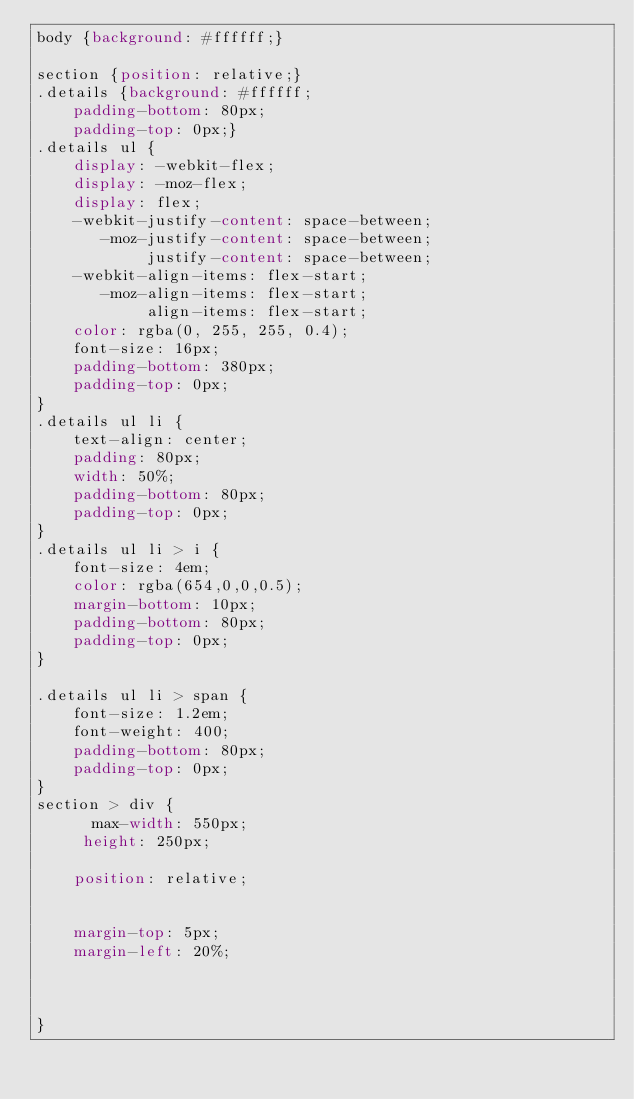Convert code to text. <code><loc_0><loc_0><loc_500><loc_500><_CSS_>body {background: #ffffff;}

section {position: relative;}
.details {background: #ffffff;
    padding-bottom: 80px;
    padding-top: 0px;}
.details ul {
    display: -webkit-flex;
    display: -moz-flex;
    display: flex;
    -webkit-justify-content: space-between;
       -moz-justify-content: space-between;
            justify-content: space-between;
    -webkit-align-items: flex-start;
       -moz-align-items: flex-start;
            align-items: flex-start;
    color: rgba(0, 255, 255, 0.4);
    font-size: 16px;
    padding-bottom: 380px;
    padding-top: 0px;
}
.details ul li {
    text-align: center;
    padding: 80px;
    width: 50%;
	padding-bottom: 80px;
    padding-top: 0px;
}
.details ul li > i {
    font-size: 4em;
    color: rgba(654,0,0,0.5);
    margin-bottom: 10px;
	padding-bottom: 80px;
    padding-top: 0px;
}

.details ul li > span {
    font-size: 1.2em;
    font-weight: 400;
	padding-bottom: 80px;
    padding-top: 0px;
}
section > div {
      max-width: 550px; 
     height: 250px; 
	
	position: relative;
    
   
    margin-top: 5px;
	margin-left: 20%;
    
   
	
}
</code> 